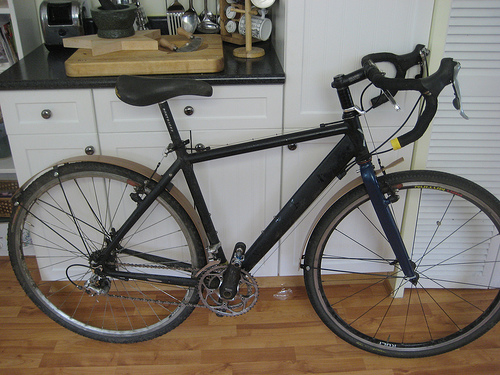<image>
Can you confirm if the bike is in front of the cutting board? Yes. The bike is positioned in front of the cutting board, appearing closer to the camera viewpoint. 